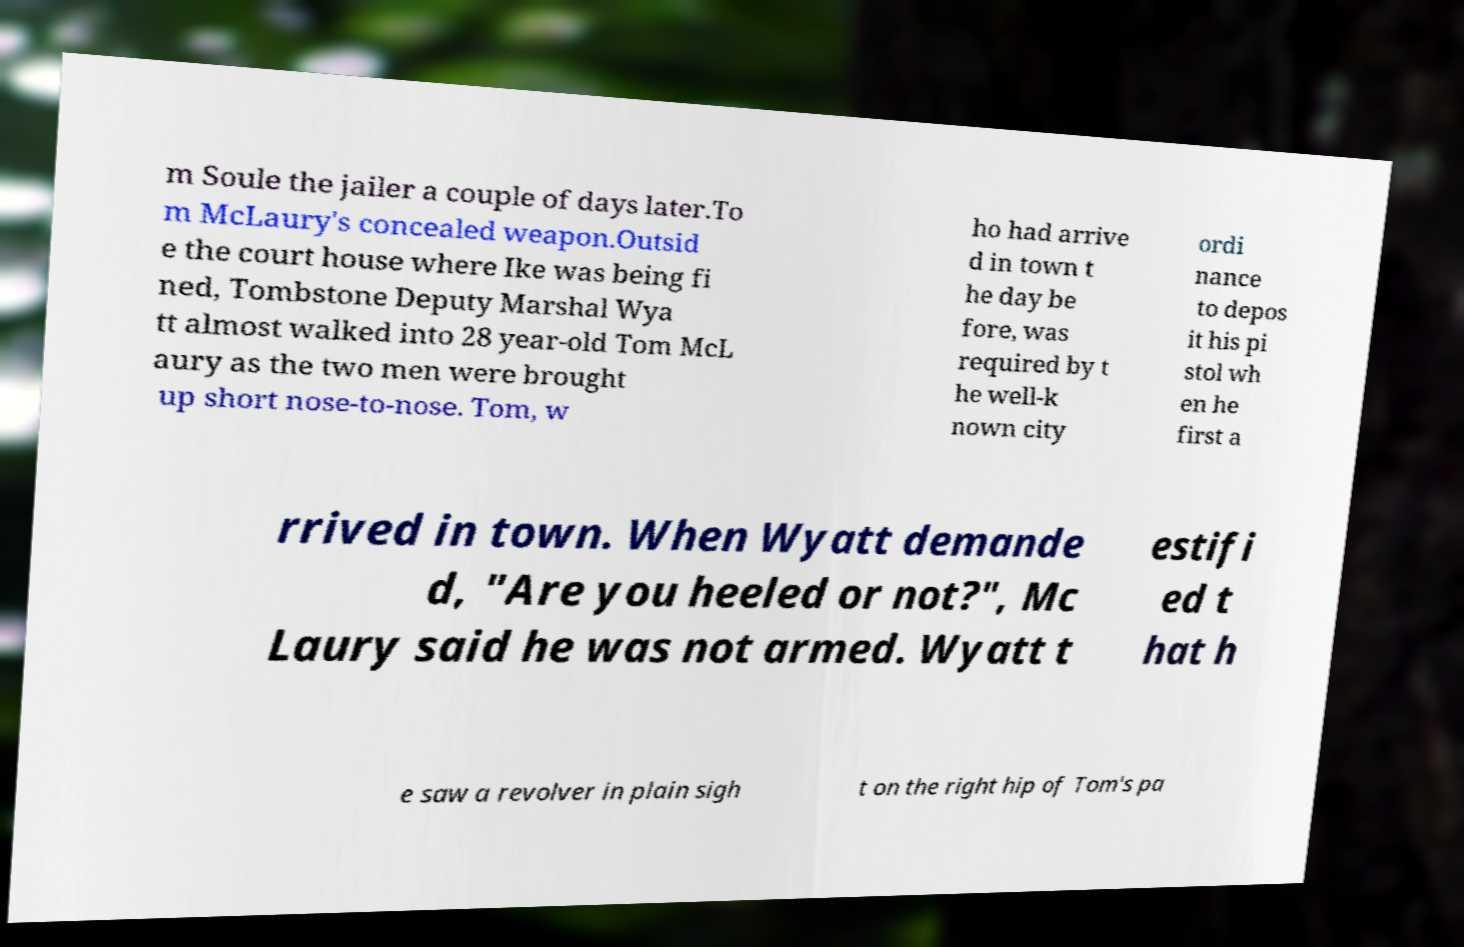Can you accurately transcribe the text from the provided image for me? m Soule the jailer a couple of days later.To m McLaury's concealed weapon.Outsid e the court house where Ike was being fi ned, Tombstone Deputy Marshal Wya tt almost walked into 28 year-old Tom McL aury as the two men were brought up short nose-to-nose. Tom, w ho had arrive d in town t he day be fore, was required by t he well-k nown city ordi nance to depos it his pi stol wh en he first a rrived in town. When Wyatt demande d, "Are you heeled or not?", Mc Laury said he was not armed. Wyatt t estifi ed t hat h e saw a revolver in plain sigh t on the right hip of Tom's pa 